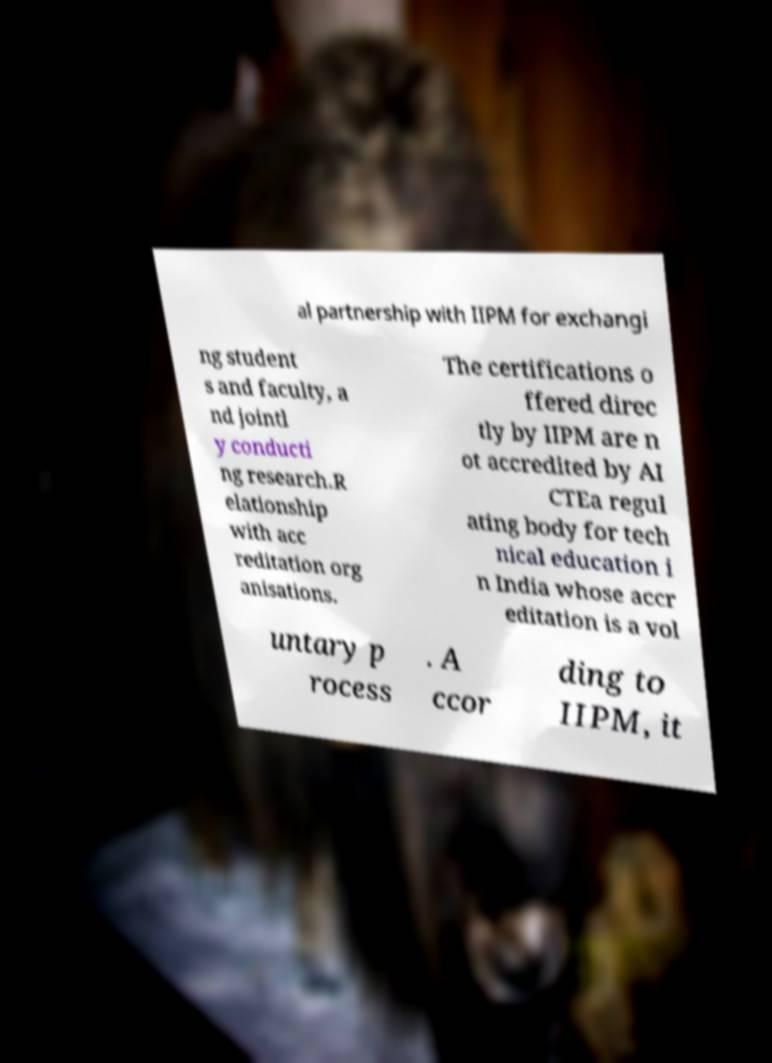Please read and relay the text visible in this image. What does it say? al partnership with IIPM for exchangi ng student s and faculty, a nd jointl y conducti ng research.R elationship with acc reditation org anisations. The certifications o ffered direc tly by IIPM are n ot accredited by AI CTEa regul ating body for tech nical education i n India whose accr editation is a vol untary p rocess . A ccor ding to IIPM, it 